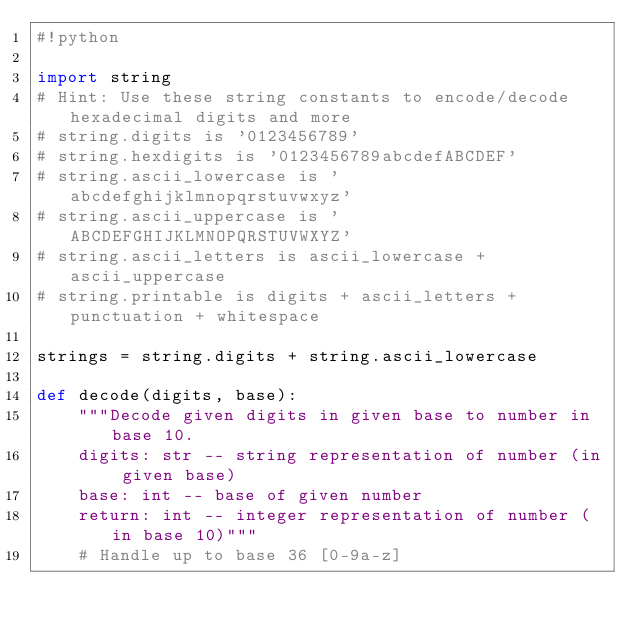Convert code to text. <code><loc_0><loc_0><loc_500><loc_500><_Python_>#!python

import string
# Hint: Use these string constants to encode/decode hexadecimal digits and more
# string.digits is '0123456789'
# string.hexdigits is '0123456789abcdefABCDEF'
# string.ascii_lowercase is 'abcdefghijklmnopqrstuvwxyz'
# string.ascii_uppercase is 'ABCDEFGHIJKLMNOPQRSTUVWXYZ'
# string.ascii_letters is ascii_lowercase + ascii_uppercase
# string.printable is digits + ascii_letters + punctuation + whitespace

strings = string.digits + string.ascii_lowercase

def decode(digits, base):
    """Decode given digits in given base to number in base 10.
    digits: str -- string representation of number (in given base)
    base: int -- base of given number
    return: int -- integer representation of number (in base 10)"""
    # Handle up to base 36 [0-9a-z]</code> 